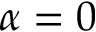<formula> <loc_0><loc_0><loc_500><loc_500>\alpha = 0</formula> 